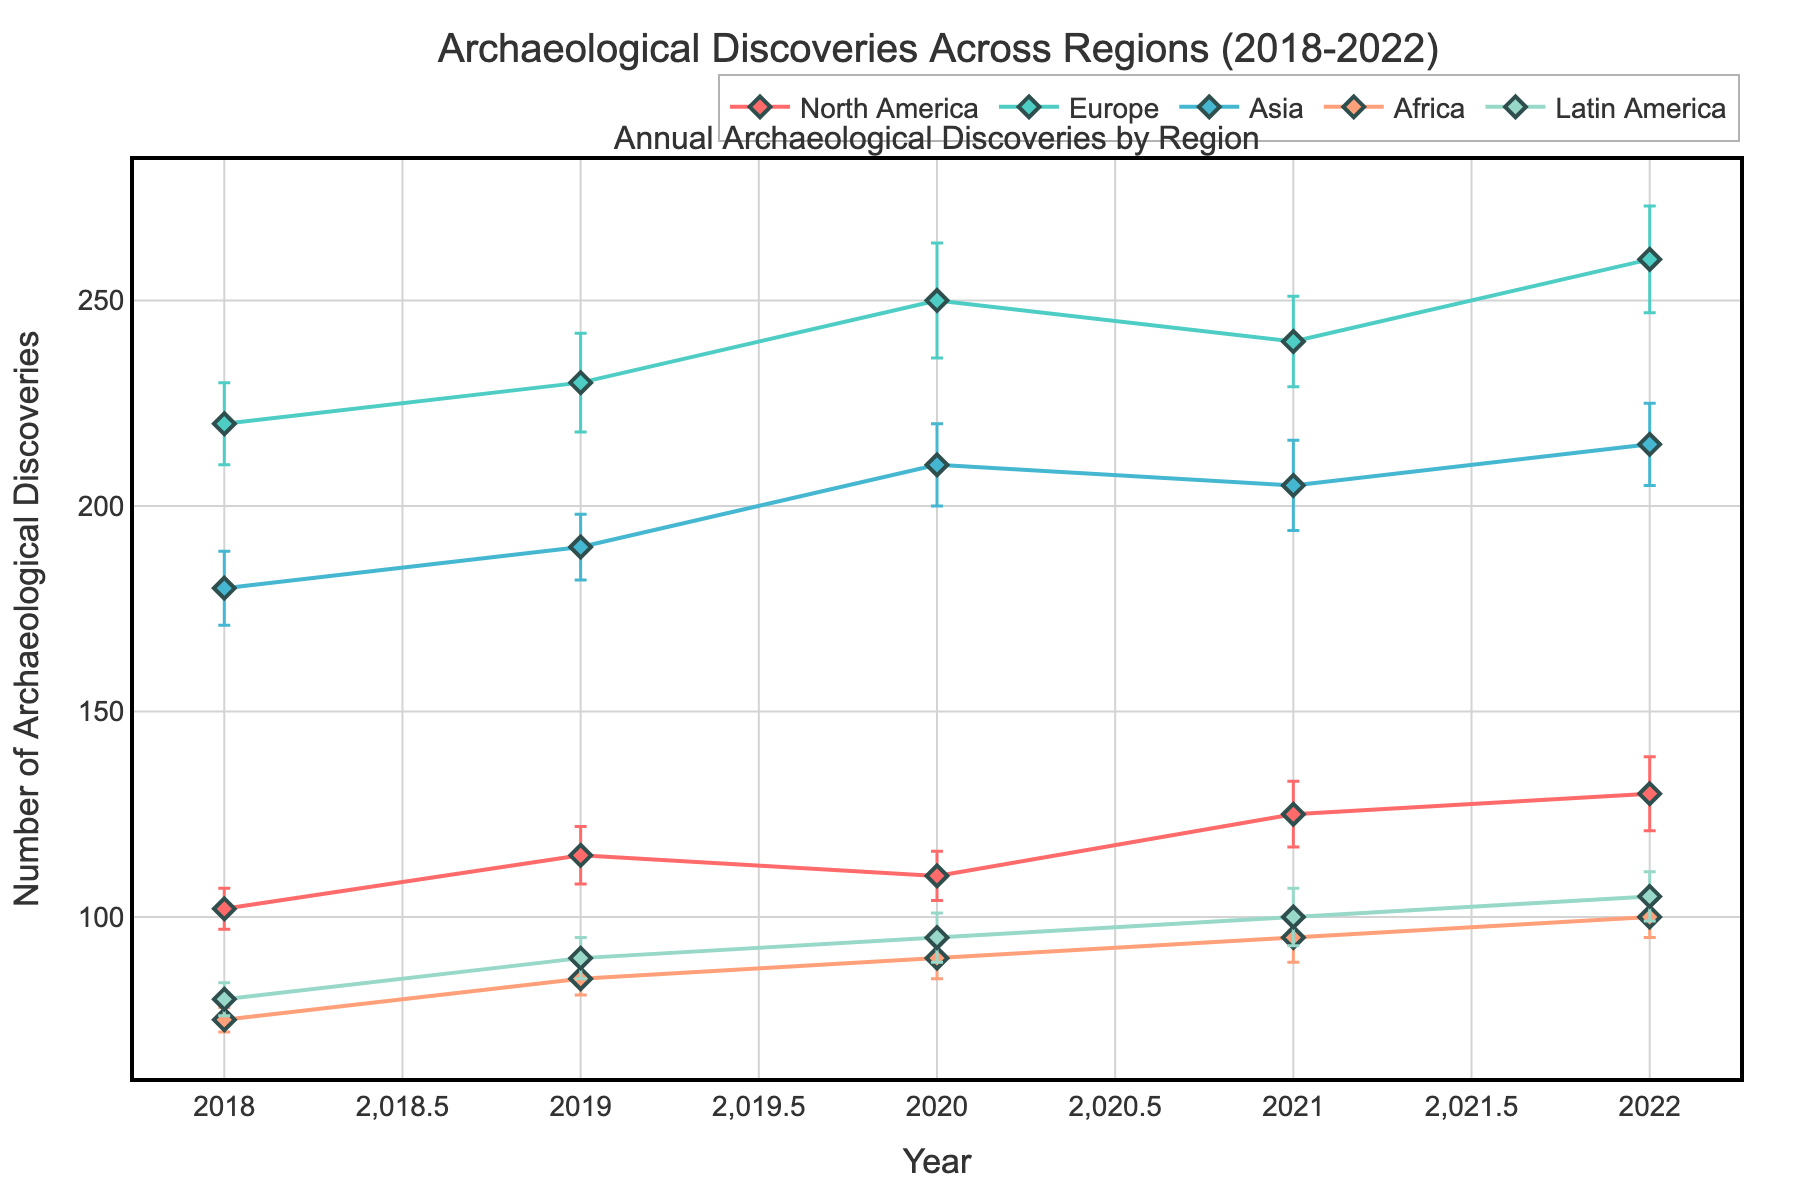What is the title of the plot? The title of the plot is "Archaeological Discoveries Across Regions (2018-2022)" as seen in the annotation at the top of the figure.
Answer: Archaeological Discoveries Across Regions (2018-2022) How many data points are there for Europe? Each region has data points for the years 2018 to 2022. By examining the lines and markers for Europe, we can count five data points.
Answer: 5 Which region had the highest number of archaeological discoveries in 2022? By looking at the markers for the year 2022, we can see that Europe had the highest number of discoveries, marked at 260 discoveries.
Answer: Europe What is the difference in the number of archaeological discoveries between North America and Asia in 2020? North America's discoveries in 2020 are 110, while Asia's discoveries in the same year are 210. The difference is 210 - 110 = 100.
Answer: 100 Which region showed the greatest increase in archaeological discoveries from 2019 to 2020? By comparing the data points for 2019 and 2020 across regions, Europe increased from 230 to 250 (a difference of 20), which is the greatest increase among the regions.
Answer: Europe What is the average number of archaeological discoveries for Latin America across the years 2018-2022? The numbers for Latin America are 80, 90, 95, 100, and 105. The average is (80 + 90 + 95 + 100 + 105) / 5 = 94.
Answer: 94 What is the range of error forecasts for Africa over the period 2018-2022? The error forecasts for Africa are 3, 4, 5, 6, and 5. The range is calculated as the highest forecast (6) minus the lowest forecast (3), which is 6 - 3 = 3.
Answer: 3 During which year did North America have the minimum number of archaeological discoveries? By checking the markers for North America, 2018 shows the minimum with 102 discoveries.
Answer: 2018 Which region has the widest error bars? By closely examining the lengths of error bars, Europe consistently has the widest error bars, peaking at 14 in 2020.
Answer: Europe 